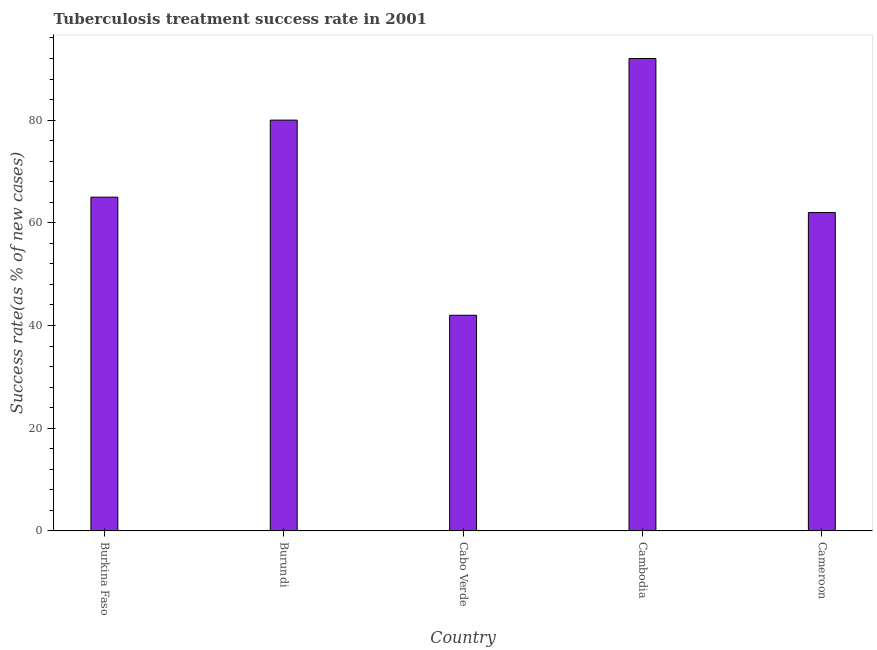Does the graph contain any zero values?
Provide a short and direct response. No. What is the title of the graph?
Ensure brevity in your answer.  Tuberculosis treatment success rate in 2001. What is the label or title of the Y-axis?
Ensure brevity in your answer.  Success rate(as % of new cases). What is the tuberculosis treatment success rate in Cameroon?
Offer a terse response. 62. Across all countries, what is the maximum tuberculosis treatment success rate?
Provide a short and direct response. 92. In which country was the tuberculosis treatment success rate maximum?
Provide a succinct answer. Cambodia. In which country was the tuberculosis treatment success rate minimum?
Your answer should be compact. Cabo Verde. What is the sum of the tuberculosis treatment success rate?
Offer a very short reply. 341. What is the difference between the tuberculosis treatment success rate in Cabo Verde and Cameroon?
Your response must be concise. -20. What is the average tuberculosis treatment success rate per country?
Provide a short and direct response. 68. What is the median tuberculosis treatment success rate?
Your answer should be very brief. 65. What is the ratio of the tuberculosis treatment success rate in Burundi to that in Cabo Verde?
Ensure brevity in your answer.  1.91. What is the difference between the highest and the second highest tuberculosis treatment success rate?
Provide a succinct answer. 12. Is the sum of the tuberculosis treatment success rate in Burkina Faso and Cameroon greater than the maximum tuberculosis treatment success rate across all countries?
Your answer should be very brief. Yes. Are the values on the major ticks of Y-axis written in scientific E-notation?
Your answer should be compact. No. What is the Success rate(as % of new cases) of Burkina Faso?
Give a very brief answer. 65. What is the Success rate(as % of new cases) in Burundi?
Offer a very short reply. 80. What is the Success rate(as % of new cases) of Cambodia?
Keep it short and to the point. 92. What is the Success rate(as % of new cases) in Cameroon?
Offer a terse response. 62. What is the difference between the Success rate(as % of new cases) in Burkina Faso and Burundi?
Your response must be concise. -15. What is the difference between the Success rate(as % of new cases) in Burkina Faso and Cabo Verde?
Make the answer very short. 23. What is the difference between the Success rate(as % of new cases) in Burkina Faso and Cambodia?
Offer a very short reply. -27. What is the difference between the Success rate(as % of new cases) in Burundi and Cabo Verde?
Offer a terse response. 38. What is the difference between the Success rate(as % of new cases) in Burundi and Cambodia?
Your answer should be compact. -12. What is the difference between the Success rate(as % of new cases) in Cabo Verde and Cambodia?
Offer a terse response. -50. What is the difference between the Success rate(as % of new cases) in Cambodia and Cameroon?
Offer a very short reply. 30. What is the ratio of the Success rate(as % of new cases) in Burkina Faso to that in Burundi?
Keep it short and to the point. 0.81. What is the ratio of the Success rate(as % of new cases) in Burkina Faso to that in Cabo Verde?
Make the answer very short. 1.55. What is the ratio of the Success rate(as % of new cases) in Burkina Faso to that in Cambodia?
Keep it short and to the point. 0.71. What is the ratio of the Success rate(as % of new cases) in Burkina Faso to that in Cameroon?
Make the answer very short. 1.05. What is the ratio of the Success rate(as % of new cases) in Burundi to that in Cabo Verde?
Keep it short and to the point. 1.91. What is the ratio of the Success rate(as % of new cases) in Burundi to that in Cambodia?
Give a very brief answer. 0.87. What is the ratio of the Success rate(as % of new cases) in Burundi to that in Cameroon?
Your answer should be compact. 1.29. What is the ratio of the Success rate(as % of new cases) in Cabo Verde to that in Cambodia?
Your response must be concise. 0.46. What is the ratio of the Success rate(as % of new cases) in Cabo Verde to that in Cameroon?
Your answer should be very brief. 0.68. What is the ratio of the Success rate(as % of new cases) in Cambodia to that in Cameroon?
Ensure brevity in your answer.  1.48. 